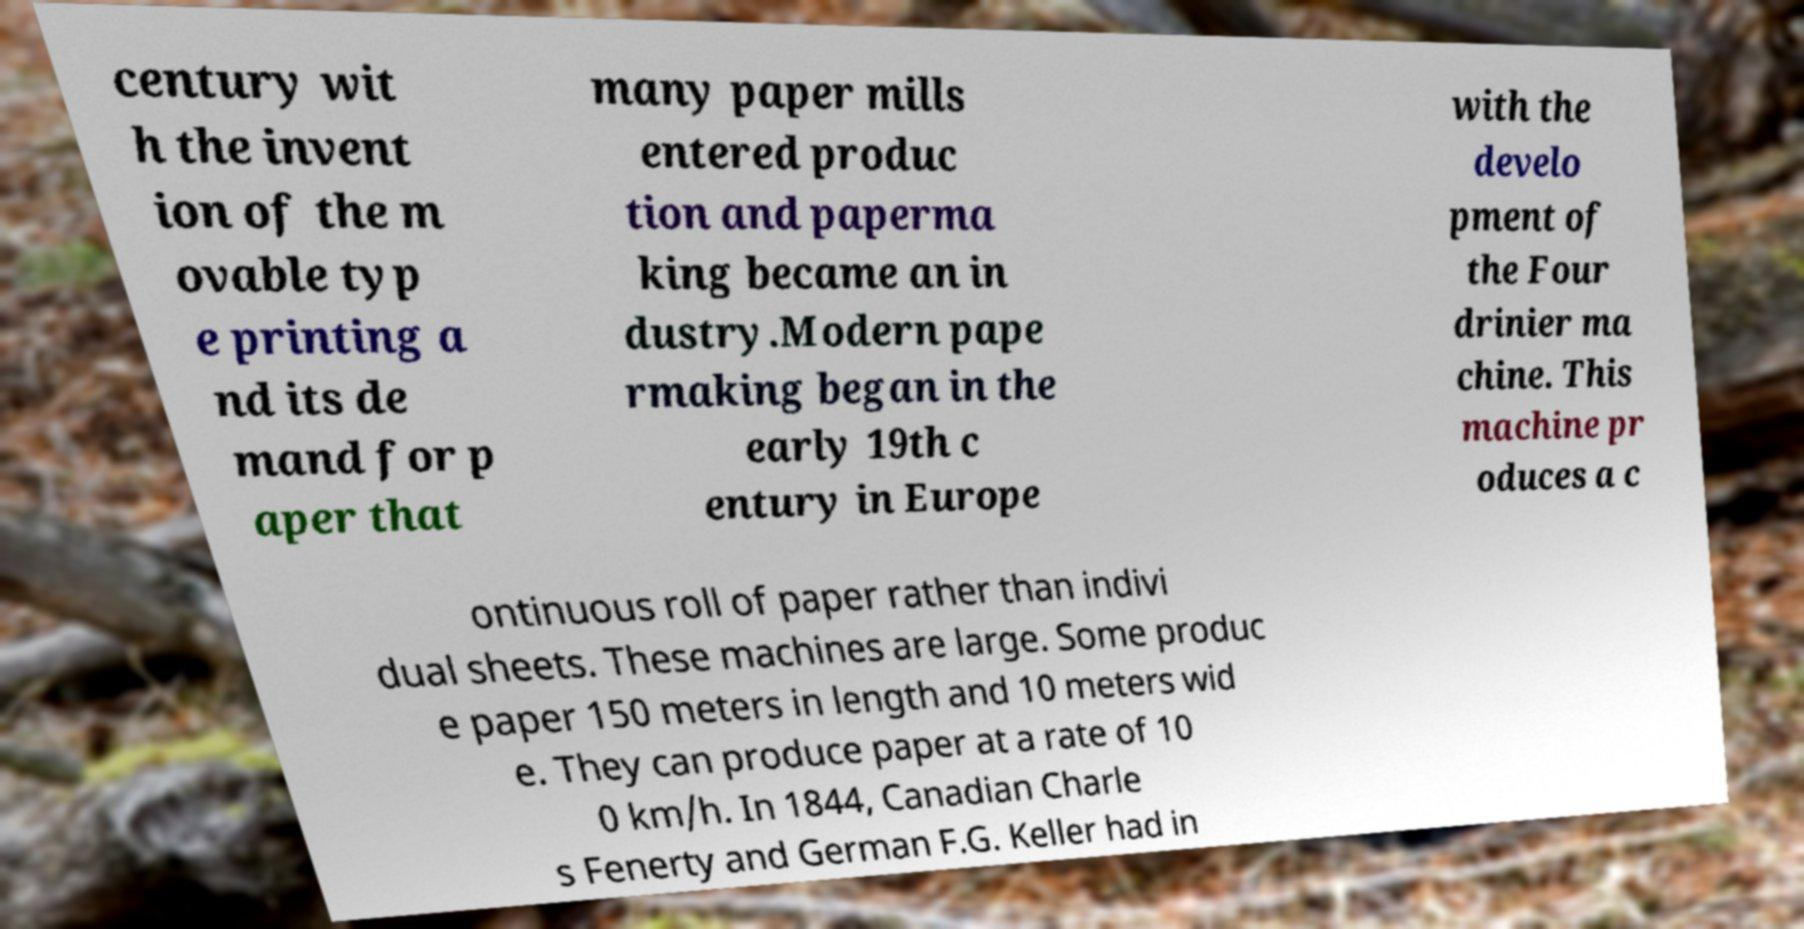Could you extract and type out the text from this image? century wit h the invent ion of the m ovable typ e printing a nd its de mand for p aper that many paper mills entered produc tion and paperma king became an in dustry.Modern pape rmaking began in the early 19th c entury in Europe with the develo pment of the Four drinier ma chine. This machine pr oduces a c ontinuous roll of paper rather than indivi dual sheets. These machines are large. Some produc e paper 150 meters in length and 10 meters wid e. They can produce paper at a rate of 10 0 km/h. In 1844, Canadian Charle s Fenerty and German F.G. Keller had in 